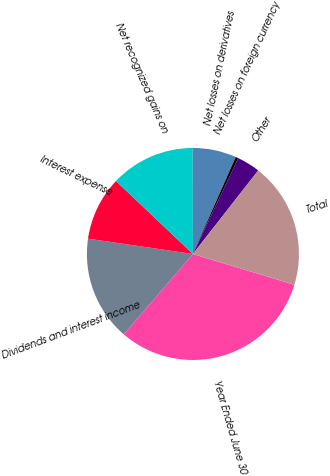<chart> <loc_0><loc_0><loc_500><loc_500><pie_chart><fcel>Year Ended June 30<fcel>Dividends and interest income<fcel>Interest expense<fcel>Net recognized gains on<fcel>Net losses on derivatives<fcel>Net losses on foreign currency<fcel>Other<fcel>Total<nl><fcel>31.61%<fcel>16.01%<fcel>9.77%<fcel>12.89%<fcel>6.65%<fcel>0.41%<fcel>3.53%<fcel>19.13%<nl></chart> 